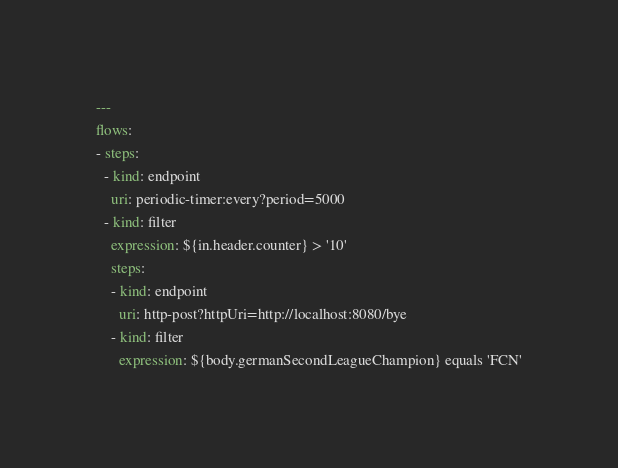Convert code to text. <code><loc_0><loc_0><loc_500><loc_500><_YAML_>---
flows:
- steps:
  - kind: endpoint
    uri: periodic-timer:every?period=5000
  - kind: filter
    expression: ${in.header.counter} > '10'
    steps:
    - kind: endpoint
      uri: http-post?httpUri=http://localhost:8080/bye
    - kind: filter
      expression: ${body.germanSecondLeagueChampion} equals 'FCN'
</code> 